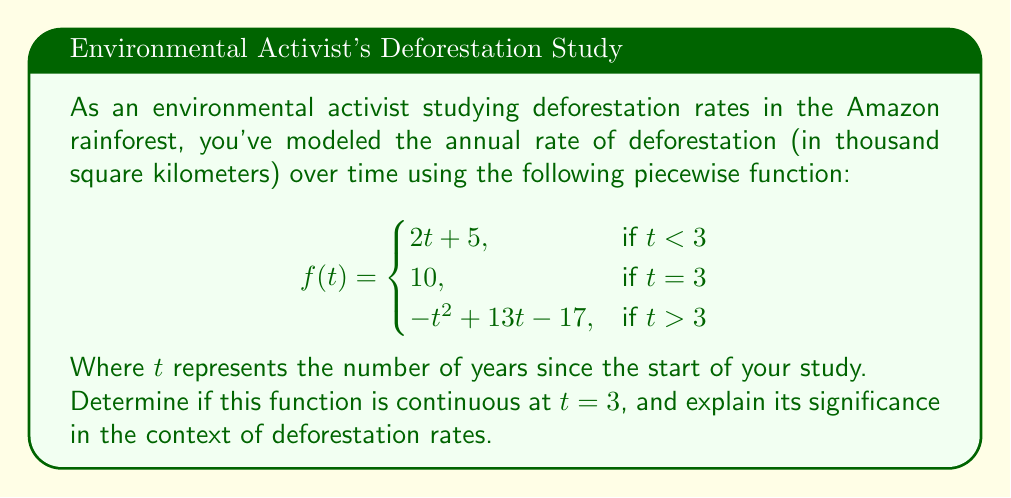Give your solution to this math problem. To determine if the function is continuous at $t = 3$, we need to check three conditions:

1. $f(3)$ exists
2. $\lim_{t \to 3^-} f(t)$ exists
3. $\lim_{t \to 3^+} f(t)$ exists
4. All three values are equal

Step 1: Check if $f(3)$ exists
$f(3) = 10$ (given in the piecewise function)

Step 2: Calculate $\lim_{t \to 3^-} f(t)$
Using the left piece of the function:
$\lim_{t \to 3^-} f(t) = \lim_{t \to 3^-} (2t + 5) = 2(3) + 5 = 11$

Step 3: Calculate $\lim_{t \to 3^+} f(t)$
Using the right piece of the function:
$\lim_{t \to 3^+} f(t) = \lim_{t \to 3^+} (-t^2 + 13t - 17) = -(3)^2 + 13(3) - 17 = 11$

Step 4: Compare the values
$f(3) = 10$
$\lim_{t \to 3^-} f(t) = 11$
$\lim_{t \to 3^+} f(t) = 11$

Since $f(3)$ is not equal to the left and right limits, the function is not continuous at $t = 3$.

Significance: This discontinuity suggests an abrupt change in deforestation rates at the 3-year mark of the study. It could indicate a sudden policy change, extreme weather event, or other factors affecting deforestation rates, which would be of interest to environmental activists and conservation scientists studying the Amazon rainforest.
Answer: Not continuous at $t = 3$ 